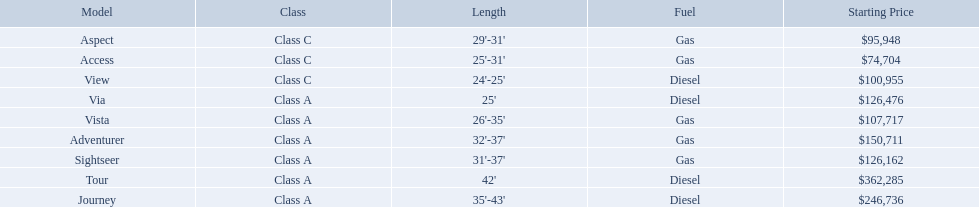Which of the models in the table use diesel fuel? Tour, Journey, Via, View. Of these models, which are class a? Tour, Journey, Via. Which of them are greater than 35' in length? Tour, Journey. Which of the two models is more expensive? Tour. 